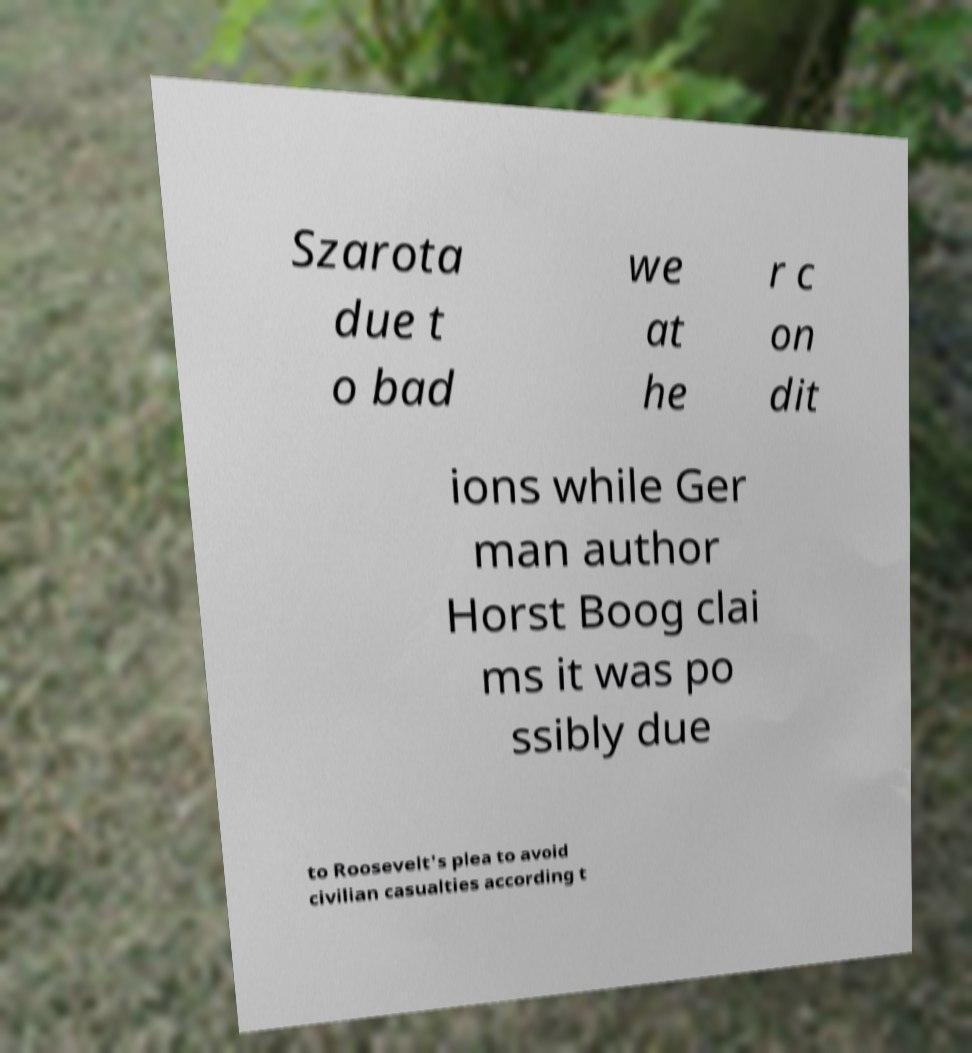Could you assist in decoding the text presented in this image and type it out clearly? Szarota due t o bad we at he r c on dit ions while Ger man author Horst Boog clai ms it was po ssibly due to Roosevelt's plea to avoid civilian casualties according t 